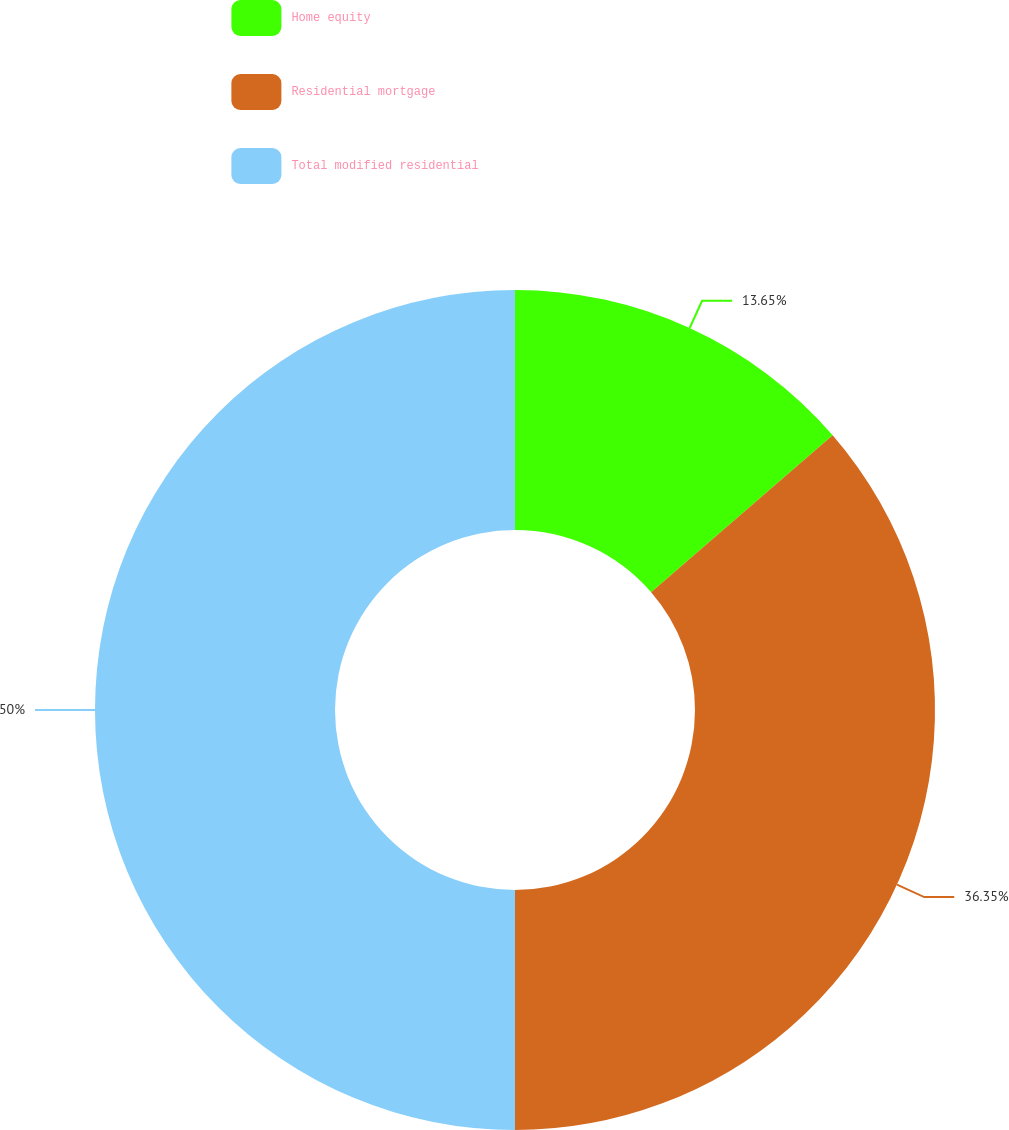Convert chart to OTSL. <chart><loc_0><loc_0><loc_500><loc_500><pie_chart><fcel>Home equity<fcel>Residential mortgage<fcel>Total modified residential<nl><fcel>13.65%<fcel>36.35%<fcel>50.0%<nl></chart> 